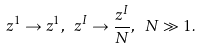<formula> <loc_0><loc_0><loc_500><loc_500>z ^ { 1 } \to z ^ { 1 } , \ z ^ { I } \to \frac { z ^ { I } } N , \ N \gg 1 .</formula> 